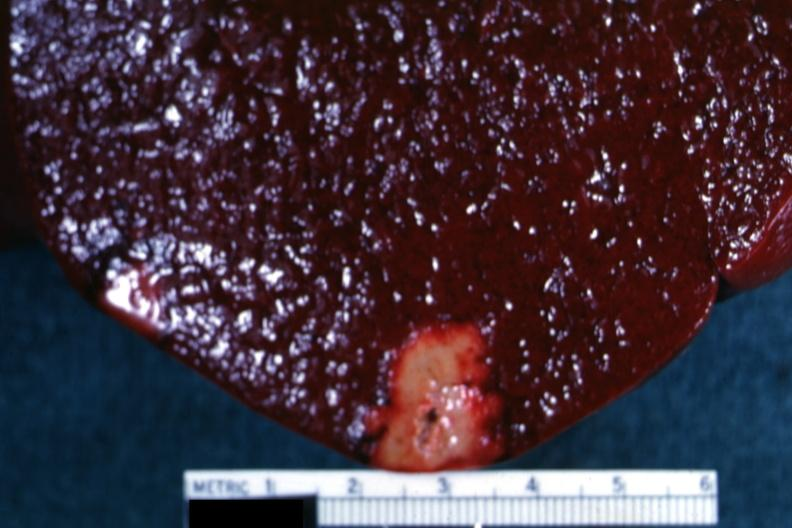what is present?
Answer the question using a single word or phrase. Spleen 